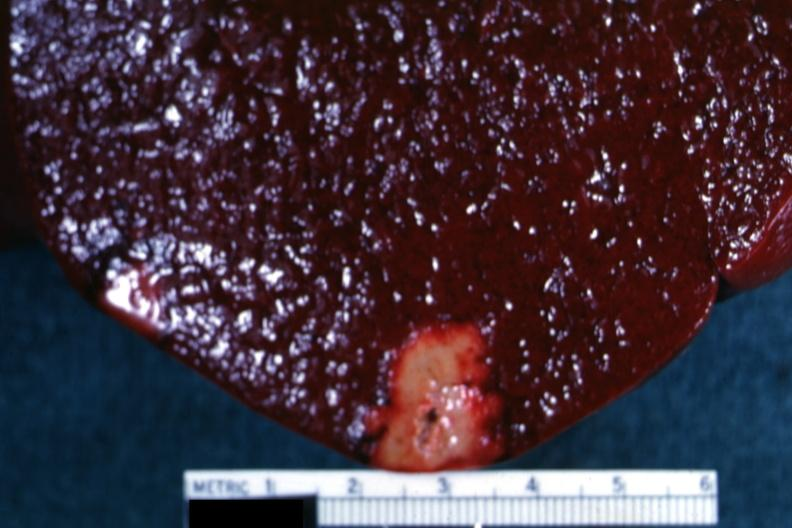what is present?
Answer the question using a single word or phrase. Spleen 